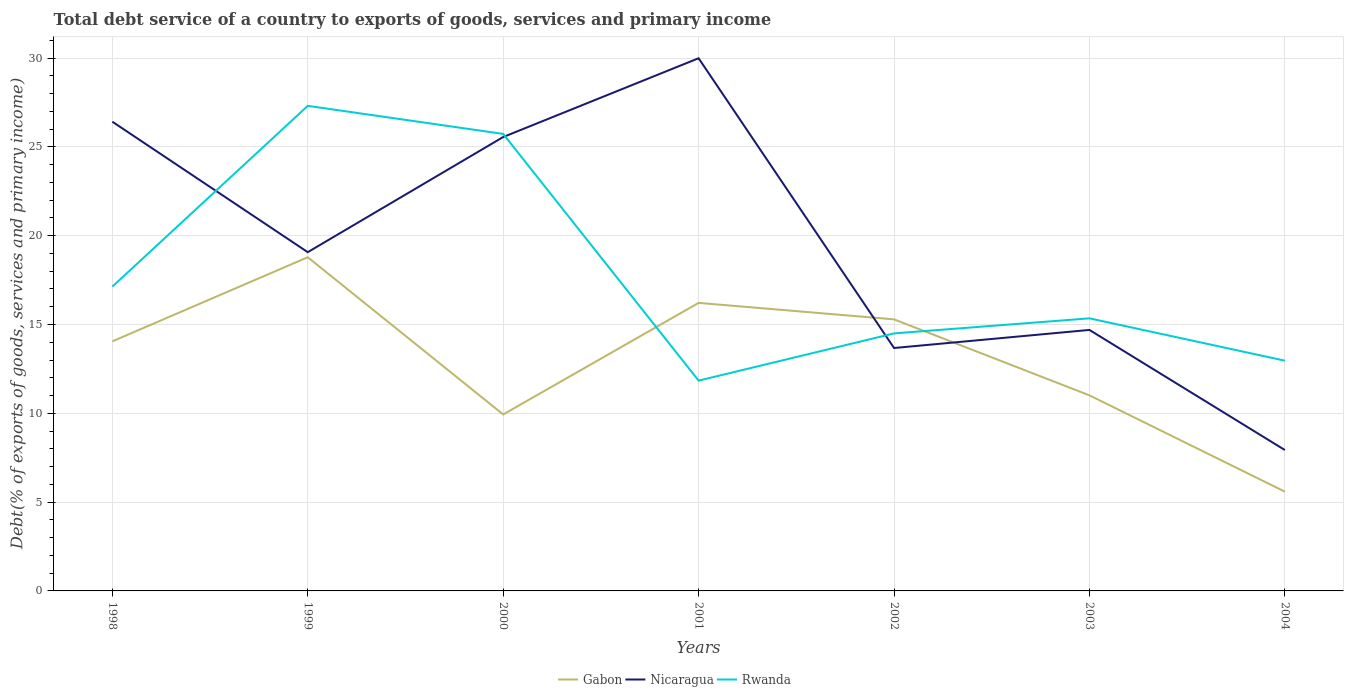How many different coloured lines are there?
Make the answer very short. 3. Does the line corresponding to Gabon intersect with the line corresponding to Nicaragua?
Keep it short and to the point. Yes. Is the number of lines equal to the number of legend labels?
Provide a short and direct response. Yes. Across all years, what is the maximum total debt service in Nicaragua?
Keep it short and to the point. 7.93. What is the total total debt service in Nicaragua in the graph?
Your response must be concise. 6.76. What is the difference between the highest and the second highest total debt service in Gabon?
Ensure brevity in your answer.  13.2. What is the difference between the highest and the lowest total debt service in Rwanda?
Offer a terse response. 2. Are the values on the major ticks of Y-axis written in scientific E-notation?
Offer a very short reply. No. Where does the legend appear in the graph?
Your answer should be compact. Bottom center. How many legend labels are there?
Make the answer very short. 3. What is the title of the graph?
Your response must be concise. Total debt service of a country to exports of goods, services and primary income. Does "Chad" appear as one of the legend labels in the graph?
Ensure brevity in your answer.  No. What is the label or title of the Y-axis?
Offer a very short reply. Debt(% of exports of goods, services and primary income). What is the Debt(% of exports of goods, services and primary income) of Gabon in 1998?
Your response must be concise. 14.05. What is the Debt(% of exports of goods, services and primary income) of Nicaragua in 1998?
Offer a terse response. 26.42. What is the Debt(% of exports of goods, services and primary income) of Rwanda in 1998?
Provide a short and direct response. 17.13. What is the Debt(% of exports of goods, services and primary income) of Gabon in 1999?
Offer a very short reply. 18.79. What is the Debt(% of exports of goods, services and primary income) of Nicaragua in 1999?
Provide a succinct answer. 19.07. What is the Debt(% of exports of goods, services and primary income) in Rwanda in 1999?
Keep it short and to the point. 27.31. What is the Debt(% of exports of goods, services and primary income) of Gabon in 2000?
Offer a terse response. 9.94. What is the Debt(% of exports of goods, services and primary income) of Nicaragua in 2000?
Offer a terse response. 25.55. What is the Debt(% of exports of goods, services and primary income) of Rwanda in 2000?
Offer a terse response. 25.73. What is the Debt(% of exports of goods, services and primary income) of Gabon in 2001?
Make the answer very short. 16.22. What is the Debt(% of exports of goods, services and primary income) in Nicaragua in 2001?
Provide a succinct answer. 29.99. What is the Debt(% of exports of goods, services and primary income) of Rwanda in 2001?
Ensure brevity in your answer.  11.84. What is the Debt(% of exports of goods, services and primary income) in Gabon in 2002?
Offer a terse response. 15.29. What is the Debt(% of exports of goods, services and primary income) in Nicaragua in 2002?
Provide a succinct answer. 13.68. What is the Debt(% of exports of goods, services and primary income) in Rwanda in 2002?
Keep it short and to the point. 14.5. What is the Debt(% of exports of goods, services and primary income) of Gabon in 2003?
Offer a very short reply. 11.01. What is the Debt(% of exports of goods, services and primary income) in Nicaragua in 2003?
Your response must be concise. 14.69. What is the Debt(% of exports of goods, services and primary income) in Rwanda in 2003?
Provide a short and direct response. 15.35. What is the Debt(% of exports of goods, services and primary income) in Gabon in 2004?
Provide a short and direct response. 5.59. What is the Debt(% of exports of goods, services and primary income) of Nicaragua in 2004?
Ensure brevity in your answer.  7.93. What is the Debt(% of exports of goods, services and primary income) of Rwanda in 2004?
Your response must be concise. 12.96. Across all years, what is the maximum Debt(% of exports of goods, services and primary income) of Gabon?
Give a very brief answer. 18.79. Across all years, what is the maximum Debt(% of exports of goods, services and primary income) in Nicaragua?
Provide a succinct answer. 29.99. Across all years, what is the maximum Debt(% of exports of goods, services and primary income) in Rwanda?
Offer a very short reply. 27.31. Across all years, what is the minimum Debt(% of exports of goods, services and primary income) in Gabon?
Your answer should be compact. 5.59. Across all years, what is the minimum Debt(% of exports of goods, services and primary income) of Nicaragua?
Provide a short and direct response. 7.93. Across all years, what is the minimum Debt(% of exports of goods, services and primary income) of Rwanda?
Keep it short and to the point. 11.84. What is the total Debt(% of exports of goods, services and primary income) in Gabon in the graph?
Offer a very short reply. 90.88. What is the total Debt(% of exports of goods, services and primary income) in Nicaragua in the graph?
Keep it short and to the point. 137.33. What is the total Debt(% of exports of goods, services and primary income) in Rwanda in the graph?
Offer a terse response. 124.82. What is the difference between the Debt(% of exports of goods, services and primary income) in Gabon in 1998 and that in 1999?
Offer a terse response. -4.73. What is the difference between the Debt(% of exports of goods, services and primary income) in Nicaragua in 1998 and that in 1999?
Your answer should be compact. 7.35. What is the difference between the Debt(% of exports of goods, services and primary income) in Rwanda in 1998 and that in 1999?
Make the answer very short. -10.18. What is the difference between the Debt(% of exports of goods, services and primary income) of Gabon in 1998 and that in 2000?
Your answer should be compact. 4.12. What is the difference between the Debt(% of exports of goods, services and primary income) in Nicaragua in 1998 and that in 2000?
Ensure brevity in your answer.  0.86. What is the difference between the Debt(% of exports of goods, services and primary income) in Rwanda in 1998 and that in 2000?
Keep it short and to the point. -8.6. What is the difference between the Debt(% of exports of goods, services and primary income) in Gabon in 1998 and that in 2001?
Offer a very short reply. -2.17. What is the difference between the Debt(% of exports of goods, services and primary income) in Nicaragua in 1998 and that in 2001?
Make the answer very short. -3.57. What is the difference between the Debt(% of exports of goods, services and primary income) in Rwanda in 1998 and that in 2001?
Ensure brevity in your answer.  5.29. What is the difference between the Debt(% of exports of goods, services and primary income) in Gabon in 1998 and that in 2002?
Provide a succinct answer. -1.24. What is the difference between the Debt(% of exports of goods, services and primary income) in Nicaragua in 1998 and that in 2002?
Offer a very short reply. 12.74. What is the difference between the Debt(% of exports of goods, services and primary income) in Rwanda in 1998 and that in 2002?
Offer a very short reply. 2.63. What is the difference between the Debt(% of exports of goods, services and primary income) of Gabon in 1998 and that in 2003?
Your answer should be compact. 3.04. What is the difference between the Debt(% of exports of goods, services and primary income) in Nicaragua in 1998 and that in 2003?
Your answer should be compact. 11.72. What is the difference between the Debt(% of exports of goods, services and primary income) in Rwanda in 1998 and that in 2003?
Offer a terse response. 1.78. What is the difference between the Debt(% of exports of goods, services and primary income) of Gabon in 1998 and that in 2004?
Give a very brief answer. 8.46. What is the difference between the Debt(% of exports of goods, services and primary income) of Nicaragua in 1998 and that in 2004?
Keep it short and to the point. 18.49. What is the difference between the Debt(% of exports of goods, services and primary income) of Rwanda in 1998 and that in 2004?
Ensure brevity in your answer.  4.17. What is the difference between the Debt(% of exports of goods, services and primary income) in Gabon in 1999 and that in 2000?
Your answer should be very brief. 8.85. What is the difference between the Debt(% of exports of goods, services and primary income) of Nicaragua in 1999 and that in 2000?
Provide a succinct answer. -6.48. What is the difference between the Debt(% of exports of goods, services and primary income) of Rwanda in 1999 and that in 2000?
Provide a short and direct response. 1.58. What is the difference between the Debt(% of exports of goods, services and primary income) of Gabon in 1999 and that in 2001?
Your response must be concise. 2.57. What is the difference between the Debt(% of exports of goods, services and primary income) in Nicaragua in 1999 and that in 2001?
Give a very brief answer. -10.92. What is the difference between the Debt(% of exports of goods, services and primary income) of Rwanda in 1999 and that in 2001?
Ensure brevity in your answer.  15.47. What is the difference between the Debt(% of exports of goods, services and primary income) in Gabon in 1999 and that in 2002?
Keep it short and to the point. 3.5. What is the difference between the Debt(% of exports of goods, services and primary income) in Nicaragua in 1999 and that in 2002?
Offer a terse response. 5.4. What is the difference between the Debt(% of exports of goods, services and primary income) in Rwanda in 1999 and that in 2002?
Ensure brevity in your answer.  12.81. What is the difference between the Debt(% of exports of goods, services and primary income) in Gabon in 1999 and that in 2003?
Offer a very short reply. 7.77. What is the difference between the Debt(% of exports of goods, services and primary income) in Nicaragua in 1999 and that in 2003?
Provide a short and direct response. 4.38. What is the difference between the Debt(% of exports of goods, services and primary income) of Rwanda in 1999 and that in 2003?
Your response must be concise. 11.96. What is the difference between the Debt(% of exports of goods, services and primary income) in Gabon in 1999 and that in 2004?
Offer a terse response. 13.2. What is the difference between the Debt(% of exports of goods, services and primary income) of Nicaragua in 1999 and that in 2004?
Your answer should be compact. 11.14. What is the difference between the Debt(% of exports of goods, services and primary income) of Rwanda in 1999 and that in 2004?
Provide a short and direct response. 14.35. What is the difference between the Debt(% of exports of goods, services and primary income) of Gabon in 2000 and that in 2001?
Provide a short and direct response. -6.28. What is the difference between the Debt(% of exports of goods, services and primary income) in Nicaragua in 2000 and that in 2001?
Make the answer very short. -4.43. What is the difference between the Debt(% of exports of goods, services and primary income) of Rwanda in 2000 and that in 2001?
Keep it short and to the point. 13.89. What is the difference between the Debt(% of exports of goods, services and primary income) in Gabon in 2000 and that in 2002?
Give a very brief answer. -5.35. What is the difference between the Debt(% of exports of goods, services and primary income) of Nicaragua in 2000 and that in 2002?
Offer a terse response. 11.88. What is the difference between the Debt(% of exports of goods, services and primary income) in Rwanda in 2000 and that in 2002?
Your answer should be compact. 11.23. What is the difference between the Debt(% of exports of goods, services and primary income) in Gabon in 2000 and that in 2003?
Provide a succinct answer. -1.08. What is the difference between the Debt(% of exports of goods, services and primary income) in Nicaragua in 2000 and that in 2003?
Your answer should be compact. 10.86. What is the difference between the Debt(% of exports of goods, services and primary income) of Rwanda in 2000 and that in 2003?
Provide a short and direct response. 10.38. What is the difference between the Debt(% of exports of goods, services and primary income) in Gabon in 2000 and that in 2004?
Your response must be concise. 4.35. What is the difference between the Debt(% of exports of goods, services and primary income) in Nicaragua in 2000 and that in 2004?
Provide a succinct answer. 17.62. What is the difference between the Debt(% of exports of goods, services and primary income) of Rwanda in 2000 and that in 2004?
Offer a very short reply. 12.77. What is the difference between the Debt(% of exports of goods, services and primary income) of Gabon in 2001 and that in 2002?
Provide a short and direct response. 0.93. What is the difference between the Debt(% of exports of goods, services and primary income) in Nicaragua in 2001 and that in 2002?
Ensure brevity in your answer.  16.31. What is the difference between the Debt(% of exports of goods, services and primary income) of Rwanda in 2001 and that in 2002?
Make the answer very short. -2.66. What is the difference between the Debt(% of exports of goods, services and primary income) of Gabon in 2001 and that in 2003?
Your response must be concise. 5.21. What is the difference between the Debt(% of exports of goods, services and primary income) in Nicaragua in 2001 and that in 2003?
Provide a succinct answer. 15.3. What is the difference between the Debt(% of exports of goods, services and primary income) in Rwanda in 2001 and that in 2003?
Offer a very short reply. -3.51. What is the difference between the Debt(% of exports of goods, services and primary income) in Gabon in 2001 and that in 2004?
Ensure brevity in your answer.  10.63. What is the difference between the Debt(% of exports of goods, services and primary income) in Nicaragua in 2001 and that in 2004?
Give a very brief answer. 22.06. What is the difference between the Debt(% of exports of goods, services and primary income) in Rwanda in 2001 and that in 2004?
Provide a succinct answer. -1.12. What is the difference between the Debt(% of exports of goods, services and primary income) of Gabon in 2002 and that in 2003?
Make the answer very short. 4.28. What is the difference between the Debt(% of exports of goods, services and primary income) in Nicaragua in 2002 and that in 2003?
Your answer should be very brief. -1.02. What is the difference between the Debt(% of exports of goods, services and primary income) of Rwanda in 2002 and that in 2003?
Give a very brief answer. -0.85. What is the difference between the Debt(% of exports of goods, services and primary income) in Gabon in 2002 and that in 2004?
Offer a very short reply. 9.7. What is the difference between the Debt(% of exports of goods, services and primary income) in Nicaragua in 2002 and that in 2004?
Offer a very short reply. 5.74. What is the difference between the Debt(% of exports of goods, services and primary income) of Rwanda in 2002 and that in 2004?
Your answer should be very brief. 1.54. What is the difference between the Debt(% of exports of goods, services and primary income) of Gabon in 2003 and that in 2004?
Provide a succinct answer. 5.42. What is the difference between the Debt(% of exports of goods, services and primary income) in Nicaragua in 2003 and that in 2004?
Your response must be concise. 6.76. What is the difference between the Debt(% of exports of goods, services and primary income) of Rwanda in 2003 and that in 2004?
Provide a succinct answer. 2.38. What is the difference between the Debt(% of exports of goods, services and primary income) in Gabon in 1998 and the Debt(% of exports of goods, services and primary income) in Nicaragua in 1999?
Your answer should be very brief. -5.02. What is the difference between the Debt(% of exports of goods, services and primary income) in Gabon in 1998 and the Debt(% of exports of goods, services and primary income) in Rwanda in 1999?
Your answer should be compact. -13.26. What is the difference between the Debt(% of exports of goods, services and primary income) of Nicaragua in 1998 and the Debt(% of exports of goods, services and primary income) of Rwanda in 1999?
Keep it short and to the point. -0.89. What is the difference between the Debt(% of exports of goods, services and primary income) in Gabon in 1998 and the Debt(% of exports of goods, services and primary income) in Nicaragua in 2000?
Offer a terse response. -11.5. What is the difference between the Debt(% of exports of goods, services and primary income) of Gabon in 1998 and the Debt(% of exports of goods, services and primary income) of Rwanda in 2000?
Give a very brief answer. -11.68. What is the difference between the Debt(% of exports of goods, services and primary income) in Nicaragua in 1998 and the Debt(% of exports of goods, services and primary income) in Rwanda in 2000?
Offer a terse response. 0.69. What is the difference between the Debt(% of exports of goods, services and primary income) of Gabon in 1998 and the Debt(% of exports of goods, services and primary income) of Nicaragua in 2001?
Your answer should be very brief. -15.94. What is the difference between the Debt(% of exports of goods, services and primary income) of Gabon in 1998 and the Debt(% of exports of goods, services and primary income) of Rwanda in 2001?
Your answer should be very brief. 2.21. What is the difference between the Debt(% of exports of goods, services and primary income) of Nicaragua in 1998 and the Debt(% of exports of goods, services and primary income) of Rwanda in 2001?
Keep it short and to the point. 14.58. What is the difference between the Debt(% of exports of goods, services and primary income) in Gabon in 1998 and the Debt(% of exports of goods, services and primary income) in Rwanda in 2002?
Ensure brevity in your answer.  -0.45. What is the difference between the Debt(% of exports of goods, services and primary income) in Nicaragua in 1998 and the Debt(% of exports of goods, services and primary income) in Rwanda in 2002?
Offer a very short reply. 11.92. What is the difference between the Debt(% of exports of goods, services and primary income) in Gabon in 1998 and the Debt(% of exports of goods, services and primary income) in Nicaragua in 2003?
Provide a succinct answer. -0.64. What is the difference between the Debt(% of exports of goods, services and primary income) in Gabon in 1998 and the Debt(% of exports of goods, services and primary income) in Rwanda in 2003?
Your response must be concise. -1.3. What is the difference between the Debt(% of exports of goods, services and primary income) in Nicaragua in 1998 and the Debt(% of exports of goods, services and primary income) in Rwanda in 2003?
Make the answer very short. 11.07. What is the difference between the Debt(% of exports of goods, services and primary income) of Gabon in 1998 and the Debt(% of exports of goods, services and primary income) of Nicaragua in 2004?
Ensure brevity in your answer.  6.12. What is the difference between the Debt(% of exports of goods, services and primary income) of Gabon in 1998 and the Debt(% of exports of goods, services and primary income) of Rwanda in 2004?
Your response must be concise. 1.09. What is the difference between the Debt(% of exports of goods, services and primary income) in Nicaragua in 1998 and the Debt(% of exports of goods, services and primary income) in Rwanda in 2004?
Provide a short and direct response. 13.46. What is the difference between the Debt(% of exports of goods, services and primary income) of Gabon in 1999 and the Debt(% of exports of goods, services and primary income) of Nicaragua in 2000?
Provide a succinct answer. -6.77. What is the difference between the Debt(% of exports of goods, services and primary income) of Gabon in 1999 and the Debt(% of exports of goods, services and primary income) of Rwanda in 2000?
Your answer should be very brief. -6.94. What is the difference between the Debt(% of exports of goods, services and primary income) of Nicaragua in 1999 and the Debt(% of exports of goods, services and primary income) of Rwanda in 2000?
Your answer should be compact. -6.66. What is the difference between the Debt(% of exports of goods, services and primary income) of Gabon in 1999 and the Debt(% of exports of goods, services and primary income) of Nicaragua in 2001?
Your answer should be compact. -11.2. What is the difference between the Debt(% of exports of goods, services and primary income) of Gabon in 1999 and the Debt(% of exports of goods, services and primary income) of Rwanda in 2001?
Keep it short and to the point. 6.95. What is the difference between the Debt(% of exports of goods, services and primary income) in Nicaragua in 1999 and the Debt(% of exports of goods, services and primary income) in Rwanda in 2001?
Provide a short and direct response. 7.23. What is the difference between the Debt(% of exports of goods, services and primary income) in Gabon in 1999 and the Debt(% of exports of goods, services and primary income) in Nicaragua in 2002?
Provide a short and direct response. 5.11. What is the difference between the Debt(% of exports of goods, services and primary income) in Gabon in 1999 and the Debt(% of exports of goods, services and primary income) in Rwanda in 2002?
Make the answer very short. 4.29. What is the difference between the Debt(% of exports of goods, services and primary income) in Nicaragua in 1999 and the Debt(% of exports of goods, services and primary income) in Rwanda in 2002?
Keep it short and to the point. 4.57. What is the difference between the Debt(% of exports of goods, services and primary income) in Gabon in 1999 and the Debt(% of exports of goods, services and primary income) in Nicaragua in 2003?
Offer a terse response. 4.09. What is the difference between the Debt(% of exports of goods, services and primary income) in Gabon in 1999 and the Debt(% of exports of goods, services and primary income) in Rwanda in 2003?
Your response must be concise. 3.44. What is the difference between the Debt(% of exports of goods, services and primary income) of Nicaragua in 1999 and the Debt(% of exports of goods, services and primary income) of Rwanda in 2003?
Your answer should be compact. 3.73. What is the difference between the Debt(% of exports of goods, services and primary income) in Gabon in 1999 and the Debt(% of exports of goods, services and primary income) in Nicaragua in 2004?
Offer a very short reply. 10.85. What is the difference between the Debt(% of exports of goods, services and primary income) of Gabon in 1999 and the Debt(% of exports of goods, services and primary income) of Rwanda in 2004?
Your answer should be compact. 5.82. What is the difference between the Debt(% of exports of goods, services and primary income) of Nicaragua in 1999 and the Debt(% of exports of goods, services and primary income) of Rwanda in 2004?
Make the answer very short. 6.11. What is the difference between the Debt(% of exports of goods, services and primary income) in Gabon in 2000 and the Debt(% of exports of goods, services and primary income) in Nicaragua in 2001?
Keep it short and to the point. -20.05. What is the difference between the Debt(% of exports of goods, services and primary income) in Gabon in 2000 and the Debt(% of exports of goods, services and primary income) in Rwanda in 2001?
Make the answer very short. -1.9. What is the difference between the Debt(% of exports of goods, services and primary income) in Nicaragua in 2000 and the Debt(% of exports of goods, services and primary income) in Rwanda in 2001?
Your answer should be very brief. 13.71. What is the difference between the Debt(% of exports of goods, services and primary income) in Gabon in 2000 and the Debt(% of exports of goods, services and primary income) in Nicaragua in 2002?
Your answer should be compact. -3.74. What is the difference between the Debt(% of exports of goods, services and primary income) of Gabon in 2000 and the Debt(% of exports of goods, services and primary income) of Rwanda in 2002?
Provide a succinct answer. -4.56. What is the difference between the Debt(% of exports of goods, services and primary income) of Nicaragua in 2000 and the Debt(% of exports of goods, services and primary income) of Rwanda in 2002?
Your response must be concise. 11.06. What is the difference between the Debt(% of exports of goods, services and primary income) of Gabon in 2000 and the Debt(% of exports of goods, services and primary income) of Nicaragua in 2003?
Offer a very short reply. -4.76. What is the difference between the Debt(% of exports of goods, services and primary income) in Gabon in 2000 and the Debt(% of exports of goods, services and primary income) in Rwanda in 2003?
Ensure brevity in your answer.  -5.41. What is the difference between the Debt(% of exports of goods, services and primary income) of Nicaragua in 2000 and the Debt(% of exports of goods, services and primary income) of Rwanda in 2003?
Keep it short and to the point. 10.21. What is the difference between the Debt(% of exports of goods, services and primary income) of Gabon in 2000 and the Debt(% of exports of goods, services and primary income) of Nicaragua in 2004?
Your response must be concise. 2. What is the difference between the Debt(% of exports of goods, services and primary income) in Gabon in 2000 and the Debt(% of exports of goods, services and primary income) in Rwanda in 2004?
Offer a terse response. -3.03. What is the difference between the Debt(% of exports of goods, services and primary income) of Nicaragua in 2000 and the Debt(% of exports of goods, services and primary income) of Rwanda in 2004?
Your answer should be compact. 12.59. What is the difference between the Debt(% of exports of goods, services and primary income) in Gabon in 2001 and the Debt(% of exports of goods, services and primary income) in Nicaragua in 2002?
Provide a short and direct response. 2.54. What is the difference between the Debt(% of exports of goods, services and primary income) of Gabon in 2001 and the Debt(% of exports of goods, services and primary income) of Rwanda in 2002?
Your response must be concise. 1.72. What is the difference between the Debt(% of exports of goods, services and primary income) in Nicaragua in 2001 and the Debt(% of exports of goods, services and primary income) in Rwanda in 2002?
Offer a terse response. 15.49. What is the difference between the Debt(% of exports of goods, services and primary income) in Gabon in 2001 and the Debt(% of exports of goods, services and primary income) in Nicaragua in 2003?
Your answer should be very brief. 1.52. What is the difference between the Debt(% of exports of goods, services and primary income) of Gabon in 2001 and the Debt(% of exports of goods, services and primary income) of Rwanda in 2003?
Your response must be concise. 0.87. What is the difference between the Debt(% of exports of goods, services and primary income) of Nicaragua in 2001 and the Debt(% of exports of goods, services and primary income) of Rwanda in 2003?
Provide a succinct answer. 14.64. What is the difference between the Debt(% of exports of goods, services and primary income) in Gabon in 2001 and the Debt(% of exports of goods, services and primary income) in Nicaragua in 2004?
Provide a succinct answer. 8.28. What is the difference between the Debt(% of exports of goods, services and primary income) in Gabon in 2001 and the Debt(% of exports of goods, services and primary income) in Rwanda in 2004?
Your answer should be very brief. 3.25. What is the difference between the Debt(% of exports of goods, services and primary income) in Nicaragua in 2001 and the Debt(% of exports of goods, services and primary income) in Rwanda in 2004?
Your response must be concise. 17.03. What is the difference between the Debt(% of exports of goods, services and primary income) in Gabon in 2002 and the Debt(% of exports of goods, services and primary income) in Nicaragua in 2003?
Provide a short and direct response. 0.6. What is the difference between the Debt(% of exports of goods, services and primary income) in Gabon in 2002 and the Debt(% of exports of goods, services and primary income) in Rwanda in 2003?
Provide a succinct answer. -0.06. What is the difference between the Debt(% of exports of goods, services and primary income) in Nicaragua in 2002 and the Debt(% of exports of goods, services and primary income) in Rwanda in 2003?
Give a very brief answer. -1.67. What is the difference between the Debt(% of exports of goods, services and primary income) of Gabon in 2002 and the Debt(% of exports of goods, services and primary income) of Nicaragua in 2004?
Your answer should be very brief. 7.36. What is the difference between the Debt(% of exports of goods, services and primary income) in Gabon in 2002 and the Debt(% of exports of goods, services and primary income) in Rwanda in 2004?
Offer a very short reply. 2.33. What is the difference between the Debt(% of exports of goods, services and primary income) in Nicaragua in 2002 and the Debt(% of exports of goods, services and primary income) in Rwanda in 2004?
Your response must be concise. 0.71. What is the difference between the Debt(% of exports of goods, services and primary income) in Gabon in 2003 and the Debt(% of exports of goods, services and primary income) in Nicaragua in 2004?
Give a very brief answer. 3.08. What is the difference between the Debt(% of exports of goods, services and primary income) of Gabon in 2003 and the Debt(% of exports of goods, services and primary income) of Rwanda in 2004?
Provide a short and direct response. -1.95. What is the difference between the Debt(% of exports of goods, services and primary income) in Nicaragua in 2003 and the Debt(% of exports of goods, services and primary income) in Rwanda in 2004?
Make the answer very short. 1.73. What is the average Debt(% of exports of goods, services and primary income) of Gabon per year?
Give a very brief answer. 12.98. What is the average Debt(% of exports of goods, services and primary income) of Nicaragua per year?
Your answer should be very brief. 19.62. What is the average Debt(% of exports of goods, services and primary income) in Rwanda per year?
Give a very brief answer. 17.83. In the year 1998, what is the difference between the Debt(% of exports of goods, services and primary income) of Gabon and Debt(% of exports of goods, services and primary income) of Nicaragua?
Offer a terse response. -12.37. In the year 1998, what is the difference between the Debt(% of exports of goods, services and primary income) in Gabon and Debt(% of exports of goods, services and primary income) in Rwanda?
Your answer should be compact. -3.08. In the year 1998, what is the difference between the Debt(% of exports of goods, services and primary income) in Nicaragua and Debt(% of exports of goods, services and primary income) in Rwanda?
Your answer should be very brief. 9.29. In the year 1999, what is the difference between the Debt(% of exports of goods, services and primary income) of Gabon and Debt(% of exports of goods, services and primary income) of Nicaragua?
Ensure brevity in your answer.  -0.29. In the year 1999, what is the difference between the Debt(% of exports of goods, services and primary income) in Gabon and Debt(% of exports of goods, services and primary income) in Rwanda?
Offer a terse response. -8.52. In the year 1999, what is the difference between the Debt(% of exports of goods, services and primary income) in Nicaragua and Debt(% of exports of goods, services and primary income) in Rwanda?
Give a very brief answer. -8.24. In the year 2000, what is the difference between the Debt(% of exports of goods, services and primary income) of Gabon and Debt(% of exports of goods, services and primary income) of Nicaragua?
Your answer should be compact. -15.62. In the year 2000, what is the difference between the Debt(% of exports of goods, services and primary income) of Gabon and Debt(% of exports of goods, services and primary income) of Rwanda?
Make the answer very short. -15.79. In the year 2000, what is the difference between the Debt(% of exports of goods, services and primary income) of Nicaragua and Debt(% of exports of goods, services and primary income) of Rwanda?
Offer a terse response. -0.18. In the year 2001, what is the difference between the Debt(% of exports of goods, services and primary income) of Gabon and Debt(% of exports of goods, services and primary income) of Nicaragua?
Your answer should be compact. -13.77. In the year 2001, what is the difference between the Debt(% of exports of goods, services and primary income) of Gabon and Debt(% of exports of goods, services and primary income) of Rwanda?
Ensure brevity in your answer.  4.38. In the year 2001, what is the difference between the Debt(% of exports of goods, services and primary income) of Nicaragua and Debt(% of exports of goods, services and primary income) of Rwanda?
Ensure brevity in your answer.  18.15. In the year 2002, what is the difference between the Debt(% of exports of goods, services and primary income) of Gabon and Debt(% of exports of goods, services and primary income) of Nicaragua?
Give a very brief answer. 1.61. In the year 2002, what is the difference between the Debt(% of exports of goods, services and primary income) in Gabon and Debt(% of exports of goods, services and primary income) in Rwanda?
Ensure brevity in your answer.  0.79. In the year 2002, what is the difference between the Debt(% of exports of goods, services and primary income) of Nicaragua and Debt(% of exports of goods, services and primary income) of Rwanda?
Offer a terse response. -0.82. In the year 2003, what is the difference between the Debt(% of exports of goods, services and primary income) of Gabon and Debt(% of exports of goods, services and primary income) of Nicaragua?
Provide a short and direct response. -3.68. In the year 2003, what is the difference between the Debt(% of exports of goods, services and primary income) of Gabon and Debt(% of exports of goods, services and primary income) of Rwanda?
Provide a succinct answer. -4.34. In the year 2003, what is the difference between the Debt(% of exports of goods, services and primary income) of Nicaragua and Debt(% of exports of goods, services and primary income) of Rwanda?
Offer a terse response. -0.65. In the year 2004, what is the difference between the Debt(% of exports of goods, services and primary income) in Gabon and Debt(% of exports of goods, services and primary income) in Nicaragua?
Your response must be concise. -2.34. In the year 2004, what is the difference between the Debt(% of exports of goods, services and primary income) of Gabon and Debt(% of exports of goods, services and primary income) of Rwanda?
Provide a short and direct response. -7.37. In the year 2004, what is the difference between the Debt(% of exports of goods, services and primary income) of Nicaragua and Debt(% of exports of goods, services and primary income) of Rwanda?
Offer a terse response. -5.03. What is the ratio of the Debt(% of exports of goods, services and primary income) in Gabon in 1998 to that in 1999?
Your response must be concise. 0.75. What is the ratio of the Debt(% of exports of goods, services and primary income) of Nicaragua in 1998 to that in 1999?
Provide a short and direct response. 1.39. What is the ratio of the Debt(% of exports of goods, services and primary income) of Rwanda in 1998 to that in 1999?
Provide a succinct answer. 0.63. What is the ratio of the Debt(% of exports of goods, services and primary income) in Gabon in 1998 to that in 2000?
Provide a succinct answer. 1.41. What is the ratio of the Debt(% of exports of goods, services and primary income) in Nicaragua in 1998 to that in 2000?
Your answer should be compact. 1.03. What is the ratio of the Debt(% of exports of goods, services and primary income) in Rwanda in 1998 to that in 2000?
Provide a short and direct response. 0.67. What is the ratio of the Debt(% of exports of goods, services and primary income) in Gabon in 1998 to that in 2001?
Provide a short and direct response. 0.87. What is the ratio of the Debt(% of exports of goods, services and primary income) of Nicaragua in 1998 to that in 2001?
Give a very brief answer. 0.88. What is the ratio of the Debt(% of exports of goods, services and primary income) in Rwanda in 1998 to that in 2001?
Your response must be concise. 1.45. What is the ratio of the Debt(% of exports of goods, services and primary income) of Gabon in 1998 to that in 2002?
Your response must be concise. 0.92. What is the ratio of the Debt(% of exports of goods, services and primary income) in Nicaragua in 1998 to that in 2002?
Your response must be concise. 1.93. What is the ratio of the Debt(% of exports of goods, services and primary income) of Rwanda in 1998 to that in 2002?
Keep it short and to the point. 1.18. What is the ratio of the Debt(% of exports of goods, services and primary income) of Gabon in 1998 to that in 2003?
Keep it short and to the point. 1.28. What is the ratio of the Debt(% of exports of goods, services and primary income) of Nicaragua in 1998 to that in 2003?
Provide a short and direct response. 1.8. What is the ratio of the Debt(% of exports of goods, services and primary income) in Rwanda in 1998 to that in 2003?
Offer a very short reply. 1.12. What is the ratio of the Debt(% of exports of goods, services and primary income) of Gabon in 1998 to that in 2004?
Your answer should be compact. 2.51. What is the ratio of the Debt(% of exports of goods, services and primary income) of Nicaragua in 1998 to that in 2004?
Give a very brief answer. 3.33. What is the ratio of the Debt(% of exports of goods, services and primary income) in Rwanda in 1998 to that in 2004?
Your answer should be very brief. 1.32. What is the ratio of the Debt(% of exports of goods, services and primary income) of Gabon in 1999 to that in 2000?
Your response must be concise. 1.89. What is the ratio of the Debt(% of exports of goods, services and primary income) in Nicaragua in 1999 to that in 2000?
Make the answer very short. 0.75. What is the ratio of the Debt(% of exports of goods, services and primary income) in Rwanda in 1999 to that in 2000?
Keep it short and to the point. 1.06. What is the ratio of the Debt(% of exports of goods, services and primary income) of Gabon in 1999 to that in 2001?
Give a very brief answer. 1.16. What is the ratio of the Debt(% of exports of goods, services and primary income) in Nicaragua in 1999 to that in 2001?
Your response must be concise. 0.64. What is the ratio of the Debt(% of exports of goods, services and primary income) in Rwanda in 1999 to that in 2001?
Provide a succinct answer. 2.31. What is the ratio of the Debt(% of exports of goods, services and primary income) of Gabon in 1999 to that in 2002?
Provide a short and direct response. 1.23. What is the ratio of the Debt(% of exports of goods, services and primary income) of Nicaragua in 1999 to that in 2002?
Provide a succinct answer. 1.39. What is the ratio of the Debt(% of exports of goods, services and primary income) in Rwanda in 1999 to that in 2002?
Keep it short and to the point. 1.88. What is the ratio of the Debt(% of exports of goods, services and primary income) of Gabon in 1999 to that in 2003?
Your answer should be compact. 1.71. What is the ratio of the Debt(% of exports of goods, services and primary income) in Nicaragua in 1999 to that in 2003?
Your answer should be compact. 1.3. What is the ratio of the Debt(% of exports of goods, services and primary income) of Rwanda in 1999 to that in 2003?
Provide a short and direct response. 1.78. What is the ratio of the Debt(% of exports of goods, services and primary income) of Gabon in 1999 to that in 2004?
Make the answer very short. 3.36. What is the ratio of the Debt(% of exports of goods, services and primary income) in Nicaragua in 1999 to that in 2004?
Offer a very short reply. 2.4. What is the ratio of the Debt(% of exports of goods, services and primary income) in Rwanda in 1999 to that in 2004?
Provide a succinct answer. 2.11. What is the ratio of the Debt(% of exports of goods, services and primary income) of Gabon in 2000 to that in 2001?
Keep it short and to the point. 0.61. What is the ratio of the Debt(% of exports of goods, services and primary income) in Nicaragua in 2000 to that in 2001?
Offer a terse response. 0.85. What is the ratio of the Debt(% of exports of goods, services and primary income) of Rwanda in 2000 to that in 2001?
Provide a succinct answer. 2.17. What is the ratio of the Debt(% of exports of goods, services and primary income) in Gabon in 2000 to that in 2002?
Provide a succinct answer. 0.65. What is the ratio of the Debt(% of exports of goods, services and primary income) of Nicaragua in 2000 to that in 2002?
Your response must be concise. 1.87. What is the ratio of the Debt(% of exports of goods, services and primary income) of Rwanda in 2000 to that in 2002?
Your answer should be compact. 1.77. What is the ratio of the Debt(% of exports of goods, services and primary income) of Gabon in 2000 to that in 2003?
Ensure brevity in your answer.  0.9. What is the ratio of the Debt(% of exports of goods, services and primary income) of Nicaragua in 2000 to that in 2003?
Keep it short and to the point. 1.74. What is the ratio of the Debt(% of exports of goods, services and primary income) in Rwanda in 2000 to that in 2003?
Your response must be concise. 1.68. What is the ratio of the Debt(% of exports of goods, services and primary income) of Gabon in 2000 to that in 2004?
Make the answer very short. 1.78. What is the ratio of the Debt(% of exports of goods, services and primary income) in Nicaragua in 2000 to that in 2004?
Make the answer very short. 3.22. What is the ratio of the Debt(% of exports of goods, services and primary income) in Rwanda in 2000 to that in 2004?
Keep it short and to the point. 1.99. What is the ratio of the Debt(% of exports of goods, services and primary income) of Gabon in 2001 to that in 2002?
Offer a terse response. 1.06. What is the ratio of the Debt(% of exports of goods, services and primary income) in Nicaragua in 2001 to that in 2002?
Provide a short and direct response. 2.19. What is the ratio of the Debt(% of exports of goods, services and primary income) in Rwanda in 2001 to that in 2002?
Offer a terse response. 0.82. What is the ratio of the Debt(% of exports of goods, services and primary income) in Gabon in 2001 to that in 2003?
Offer a very short reply. 1.47. What is the ratio of the Debt(% of exports of goods, services and primary income) of Nicaragua in 2001 to that in 2003?
Keep it short and to the point. 2.04. What is the ratio of the Debt(% of exports of goods, services and primary income) of Rwanda in 2001 to that in 2003?
Provide a short and direct response. 0.77. What is the ratio of the Debt(% of exports of goods, services and primary income) in Gabon in 2001 to that in 2004?
Offer a very short reply. 2.9. What is the ratio of the Debt(% of exports of goods, services and primary income) of Nicaragua in 2001 to that in 2004?
Offer a very short reply. 3.78. What is the ratio of the Debt(% of exports of goods, services and primary income) in Rwanda in 2001 to that in 2004?
Offer a very short reply. 0.91. What is the ratio of the Debt(% of exports of goods, services and primary income) in Gabon in 2002 to that in 2003?
Make the answer very short. 1.39. What is the ratio of the Debt(% of exports of goods, services and primary income) in Nicaragua in 2002 to that in 2003?
Offer a terse response. 0.93. What is the ratio of the Debt(% of exports of goods, services and primary income) of Rwanda in 2002 to that in 2003?
Provide a short and direct response. 0.94. What is the ratio of the Debt(% of exports of goods, services and primary income) of Gabon in 2002 to that in 2004?
Ensure brevity in your answer.  2.74. What is the ratio of the Debt(% of exports of goods, services and primary income) of Nicaragua in 2002 to that in 2004?
Keep it short and to the point. 1.72. What is the ratio of the Debt(% of exports of goods, services and primary income) in Rwanda in 2002 to that in 2004?
Ensure brevity in your answer.  1.12. What is the ratio of the Debt(% of exports of goods, services and primary income) of Gabon in 2003 to that in 2004?
Your answer should be compact. 1.97. What is the ratio of the Debt(% of exports of goods, services and primary income) of Nicaragua in 2003 to that in 2004?
Your response must be concise. 1.85. What is the ratio of the Debt(% of exports of goods, services and primary income) of Rwanda in 2003 to that in 2004?
Provide a short and direct response. 1.18. What is the difference between the highest and the second highest Debt(% of exports of goods, services and primary income) of Gabon?
Offer a terse response. 2.57. What is the difference between the highest and the second highest Debt(% of exports of goods, services and primary income) of Nicaragua?
Make the answer very short. 3.57. What is the difference between the highest and the second highest Debt(% of exports of goods, services and primary income) in Rwanda?
Provide a succinct answer. 1.58. What is the difference between the highest and the lowest Debt(% of exports of goods, services and primary income) in Gabon?
Your response must be concise. 13.2. What is the difference between the highest and the lowest Debt(% of exports of goods, services and primary income) of Nicaragua?
Your answer should be compact. 22.06. What is the difference between the highest and the lowest Debt(% of exports of goods, services and primary income) of Rwanda?
Your answer should be compact. 15.47. 